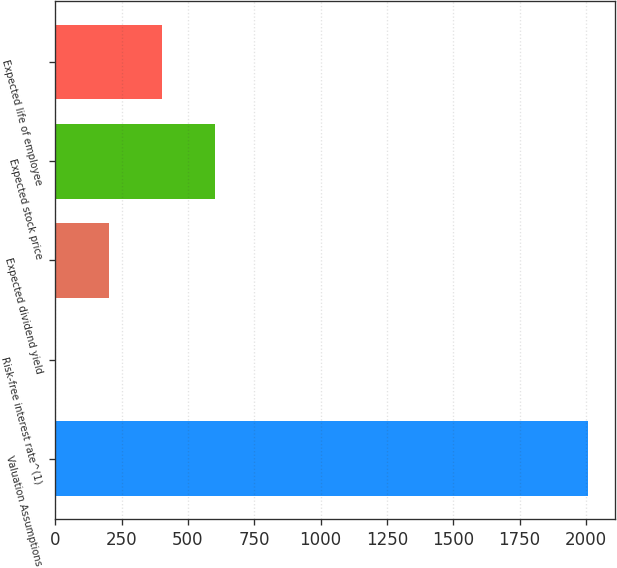<chart> <loc_0><loc_0><loc_500><loc_500><bar_chart><fcel>Valuation Assumptions<fcel>Risk-free interest rate^(1)<fcel>Expected dividend yield<fcel>Expected stock price<fcel>Expected life of employee<nl><fcel>2009<fcel>1.3<fcel>202.07<fcel>603.61<fcel>402.84<nl></chart> 